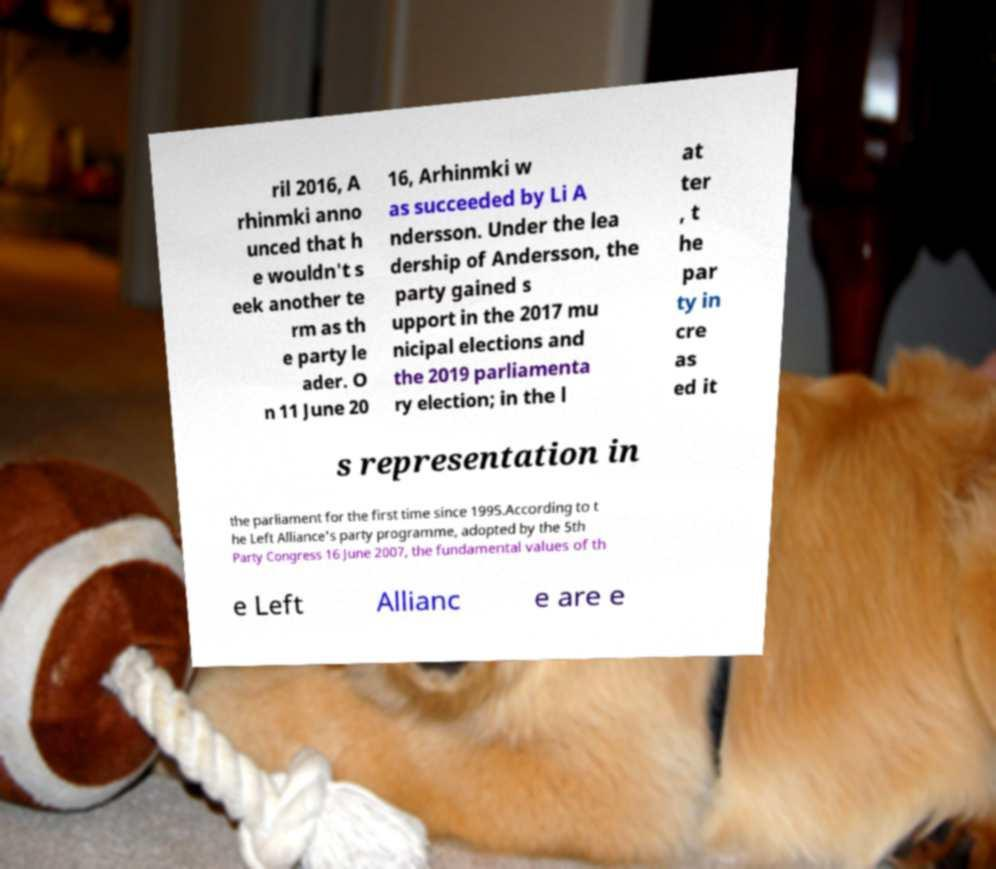For documentation purposes, I need the text within this image transcribed. Could you provide that? ril 2016, A rhinmki anno unced that h e wouldn't s eek another te rm as th e party le ader. O n 11 June 20 16, Arhinmki w as succeeded by Li A ndersson. Under the lea dership of Andersson, the party gained s upport in the 2017 mu nicipal elections and the 2019 parliamenta ry election; in the l at ter , t he par ty in cre as ed it s representation in the parliament for the first time since 1995.According to t he Left Alliance's party programme, adopted by the 5th Party Congress 16 June 2007, the fundamental values of th e Left Allianc e are e 